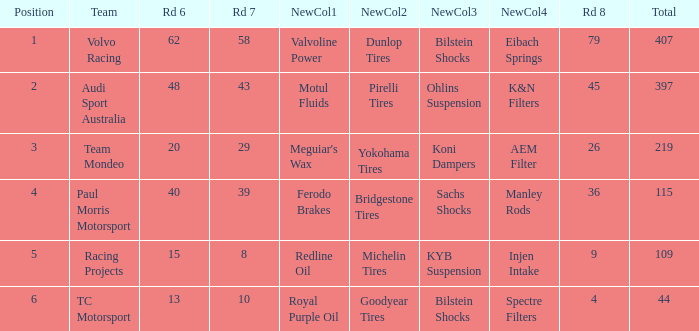What is the sum of total values for Rd 7 less than 8? None. 